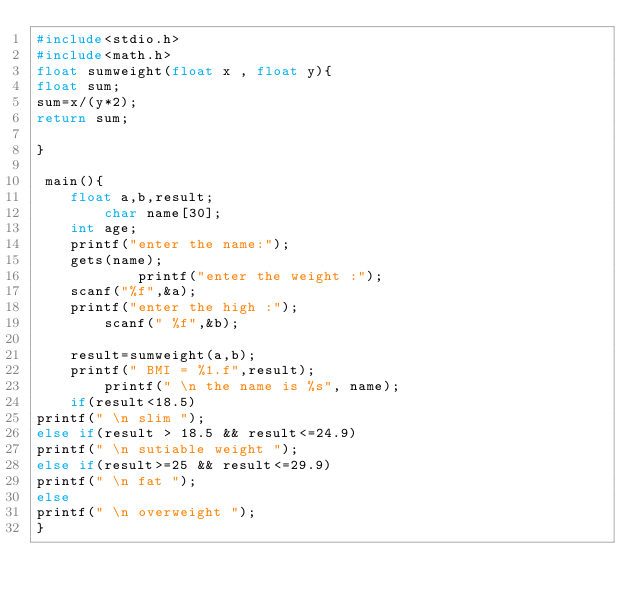Convert code to text. <code><loc_0><loc_0><loc_500><loc_500><_C++_>#include<stdio.h>
#include<math.h>
float sumweight(float x , float y){
float sum;
sum=x/(y*2);
return sum;

}

 main(){
	float a,b,result;
		char name[30];
	int age;
	printf("enter the name:");
	gets(name);
			printf("enter the weight :");
	scanf("%f",&a);
	printf("enter the high :");
		scanf(" %f",&b);

	result=sumweight(a,b);
	printf(" BMI = %1.f",result);
		printf(" \n the name is %s", name);
	if(result<18.5)
printf(" \n slim ");
else if(result > 18.5 && result<=24.9)
printf(" \n sutiable weight ");
else if(result>=25 && result<=29.9)
printf(" \n fat ");
else 
printf(" \n overweight ");
}
</code> 